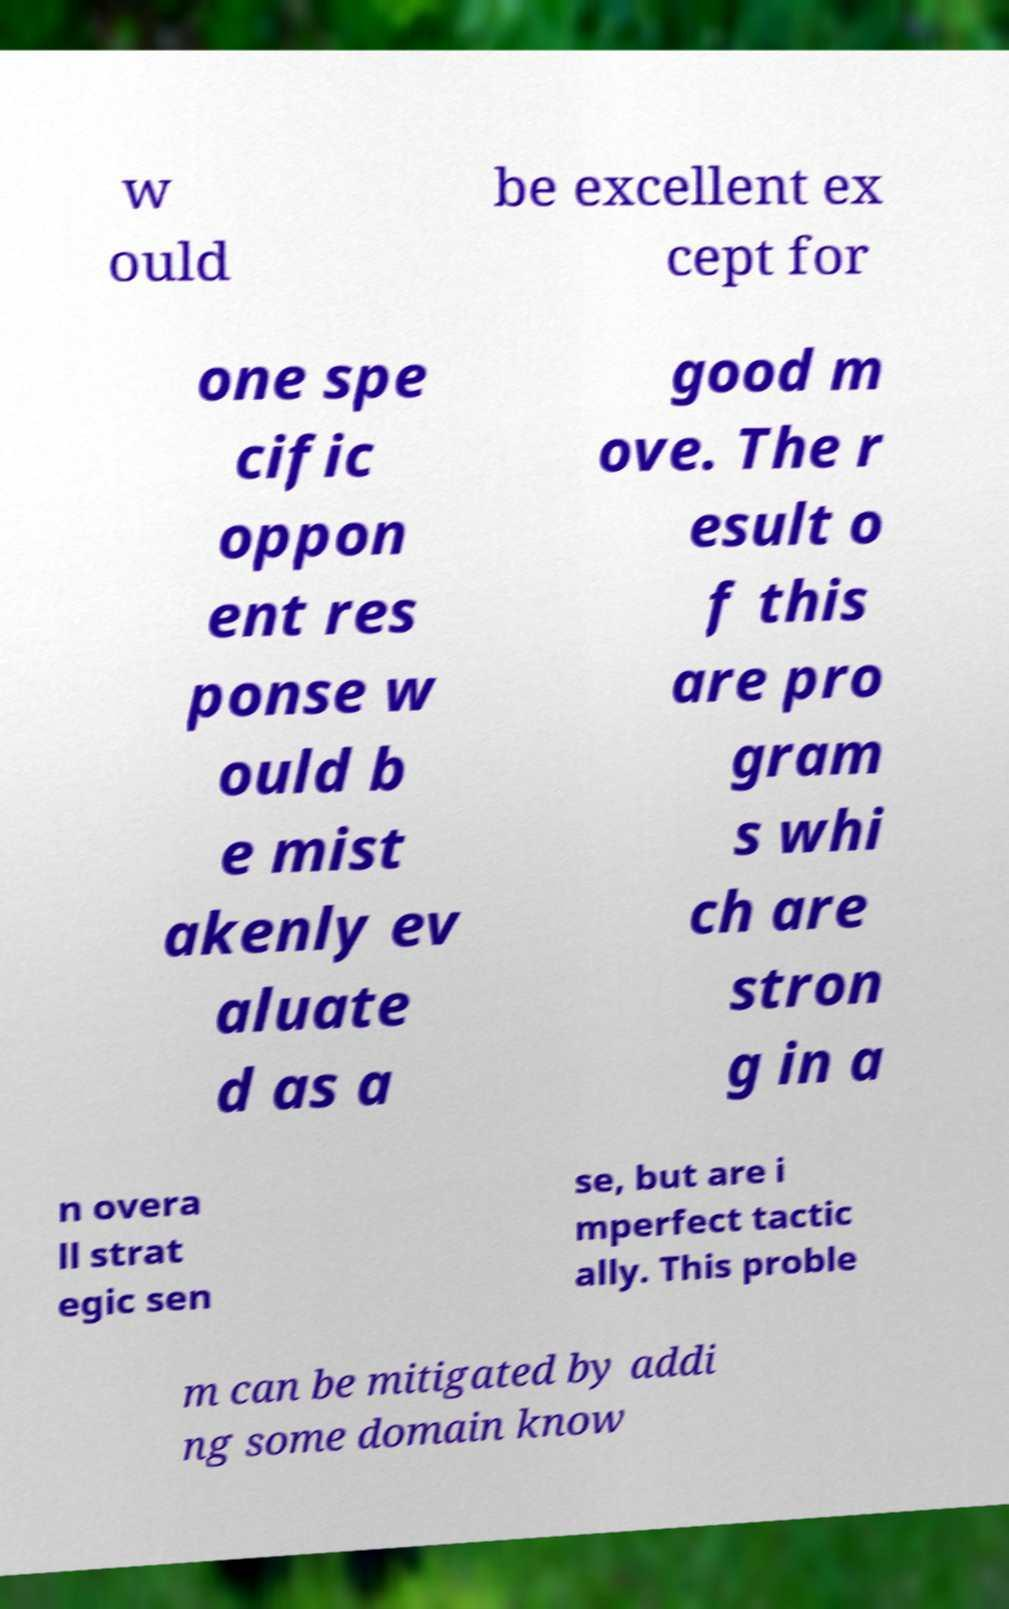Could you assist in decoding the text presented in this image and type it out clearly? w ould be excellent ex cept for one spe cific oppon ent res ponse w ould b e mist akenly ev aluate d as a good m ove. The r esult o f this are pro gram s whi ch are stron g in a n overa ll strat egic sen se, but are i mperfect tactic ally. This proble m can be mitigated by addi ng some domain know 